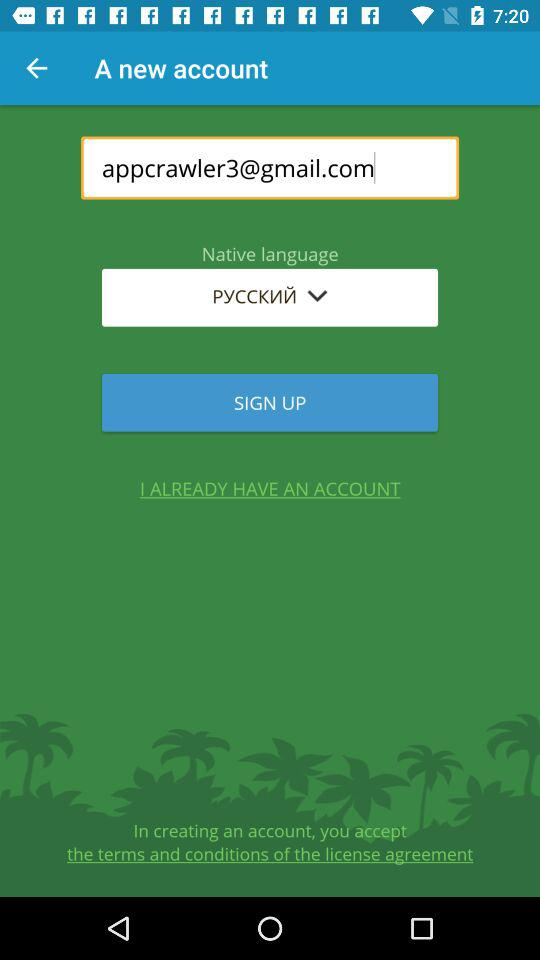Which languages are available in "Native language"?
When the provided information is insufficient, respond with <no answer>. <no answer> 